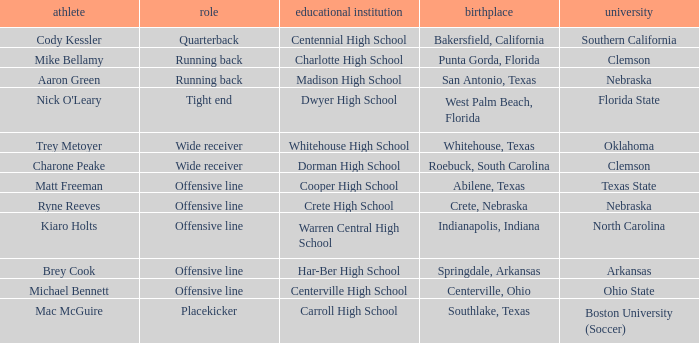What college did Matt Freeman go to? Texas State. 